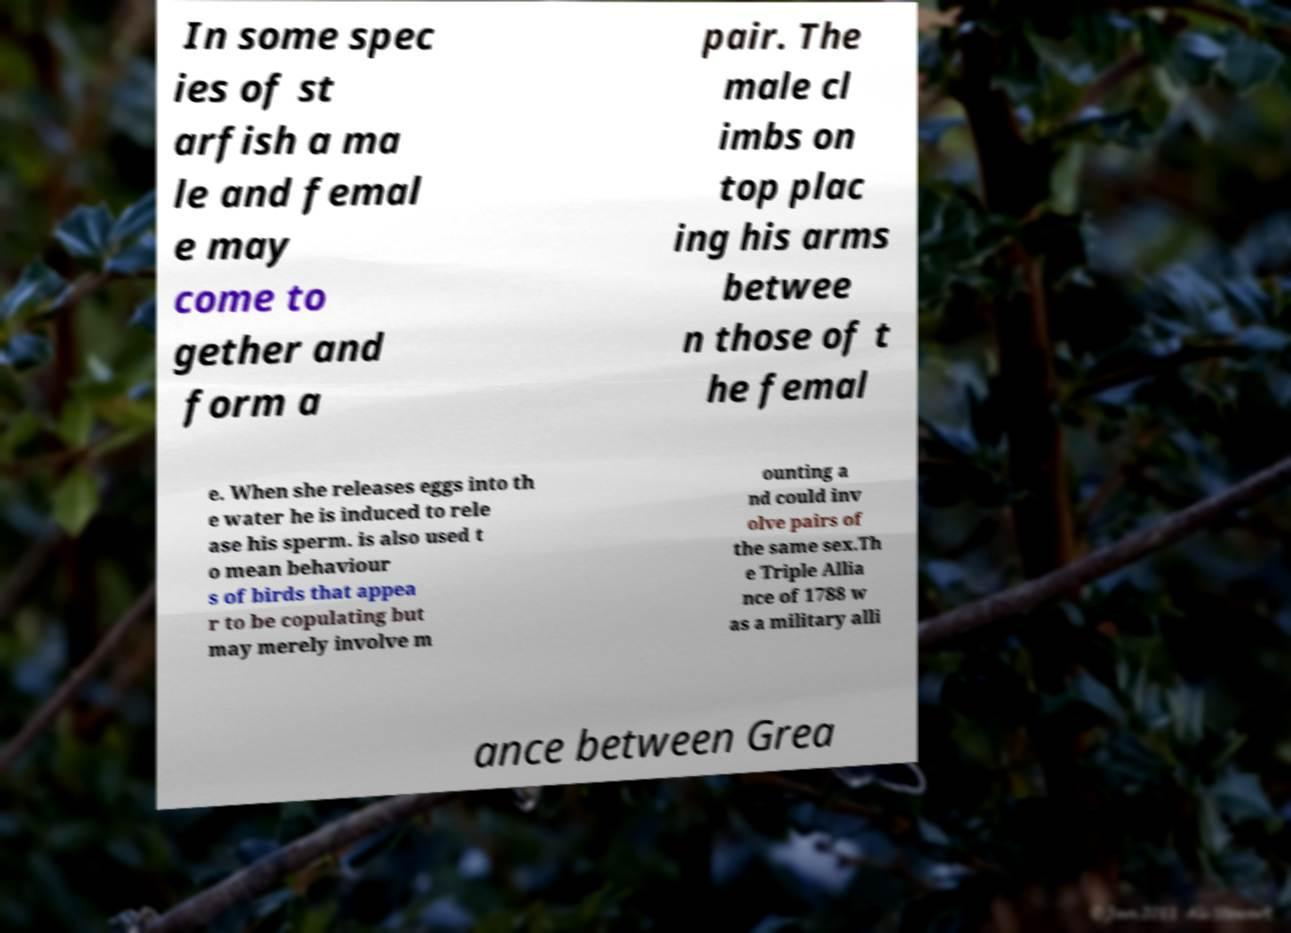What messages or text are displayed in this image? I need them in a readable, typed format. In some spec ies of st arfish a ma le and femal e may come to gether and form a pair. The male cl imbs on top plac ing his arms betwee n those of t he femal e. When she releases eggs into th e water he is induced to rele ase his sperm. is also used t o mean behaviour s of birds that appea r to be copulating but may merely involve m ounting a nd could inv olve pairs of the same sex.Th e Triple Allia nce of 1788 w as a military alli ance between Grea 